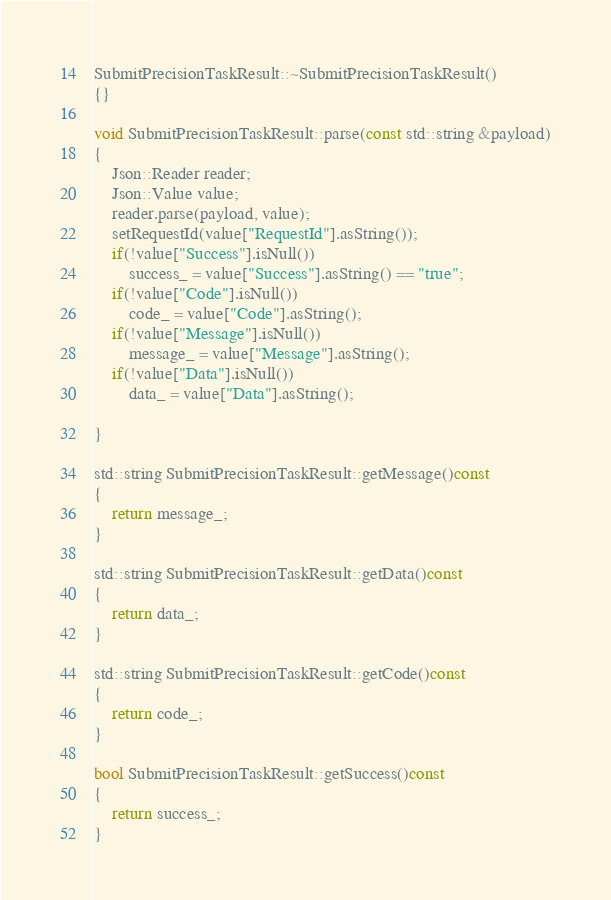<code> <loc_0><loc_0><loc_500><loc_500><_C++_>
SubmitPrecisionTaskResult::~SubmitPrecisionTaskResult()
{}

void SubmitPrecisionTaskResult::parse(const std::string &payload)
{
	Json::Reader reader;
	Json::Value value;
	reader.parse(payload, value);
	setRequestId(value["RequestId"].asString());
	if(!value["Success"].isNull())
		success_ = value["Success"].asString() == "true";
	if(!value["Code"].isNull())
		code_ = value["Code"].asString();
	if(!value["Message"].isNull())
		message_ = value["Message"].asString();
	if(!value["Data"].isNull())
		data_ = value["Data"].asString();

}

std::string SubmitPrecisionTaskResult::getMessage()const
{
	return message_;
}

std::string SubmitPrecisionTaskResult::getData()const
{
	return data_;
}

std::string SubmitPrecisionTaskResult::getCode()const
{
	return code_;
}

bool SubmitPrecisionTaskResult::getSuccess()const
{
	return success_;
}

</code> 